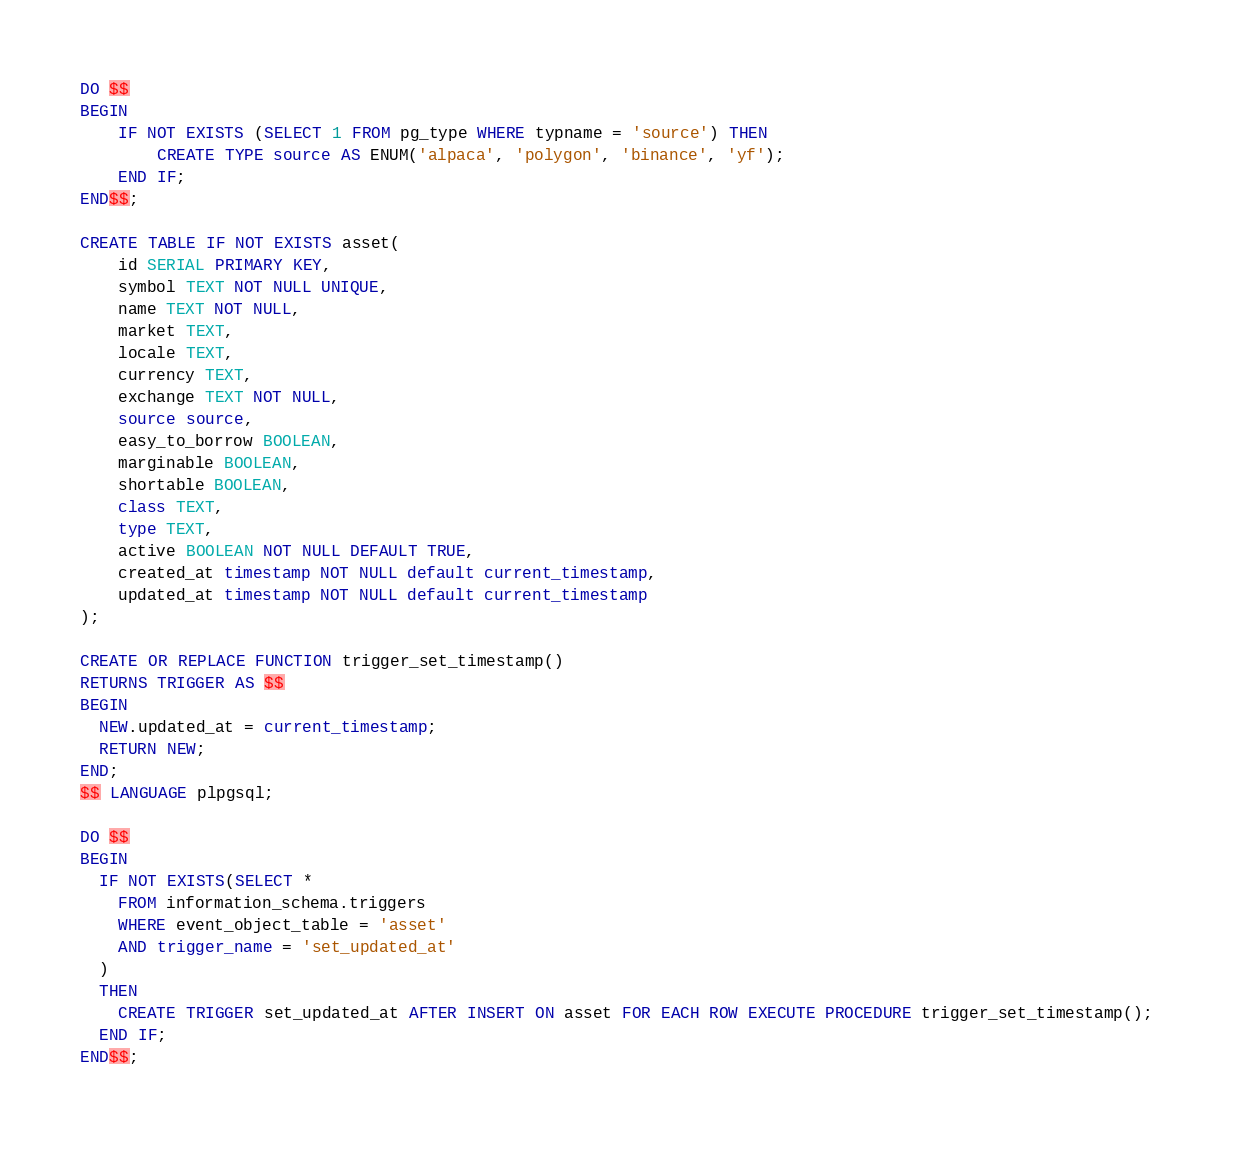Convert code to text. <code><loc_0><loc_0><loc_500><loc_500><_SQL_>DO $$
BEGIN
    IF NOT EXISTS (SELECT 1 FROM pg_type WHERE typname = 'source') THEN
        CREATE TYPE source AS ENUM('alpaca', 'polygon', 'binance', 'yf');
    END IF;
END$$;

CREATE TABLE IF NOT EXISTS asset(
    id SERIAL PRIMARY KEY, 
    symbol TEXT NOT NULL UNIQUE, 
    name TEXT NOT NULL,
    market TEXT,
    locale TEXT,
    currency TEXT,
    exchange TEXT NOT NULL,
    source source, 
    easy_to_borrow BOOLEAN,
    marginable BOOLEAN,
    shortable BOOLEAN,
    class TEXT,
    type TEXT, 
    active BOOLEAN NOT NULL DEFAULT TRUE,
    created_at timestamp NOT NULL default current_timestamp,
    updated_at timestamp NOT NULL default current_timestamp
);

CREATE OR REPLACE FUNCTION trigger_set_timestamp()
RETURNS TRIGGER AS $$
BEGIN
  NEW.updated_at = current_timestamp;
  RETURN NEW;
END;
$$ LANGUAGE plpgsql;

DO $$
BEGIN
  IF NOT EXISTS(SELECT *
    FROM information_schema.triggers
    WHERE event_object_table = 'asset'
    AND trigger_name = 'set_updated_at'
  )
  THEN
    CREATE TRIGGER set_updated_at AFTER INSERT ON asset FOR EACH ROW EXECUTE PROCEDURE trigger_set_timestamp();
  END IF;
END$$;</code> 